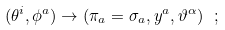Convert formula to latex. <formula><loc_0><loc_0><loc_500><loc_500>( \theta ^ { i } , \phi ^ { a } ) \rightarrow ( \pi _ { a } = \sigma _ { a } , y ^ { a } , \vartheta ^ { \alpha } ) \ ;</formula> 